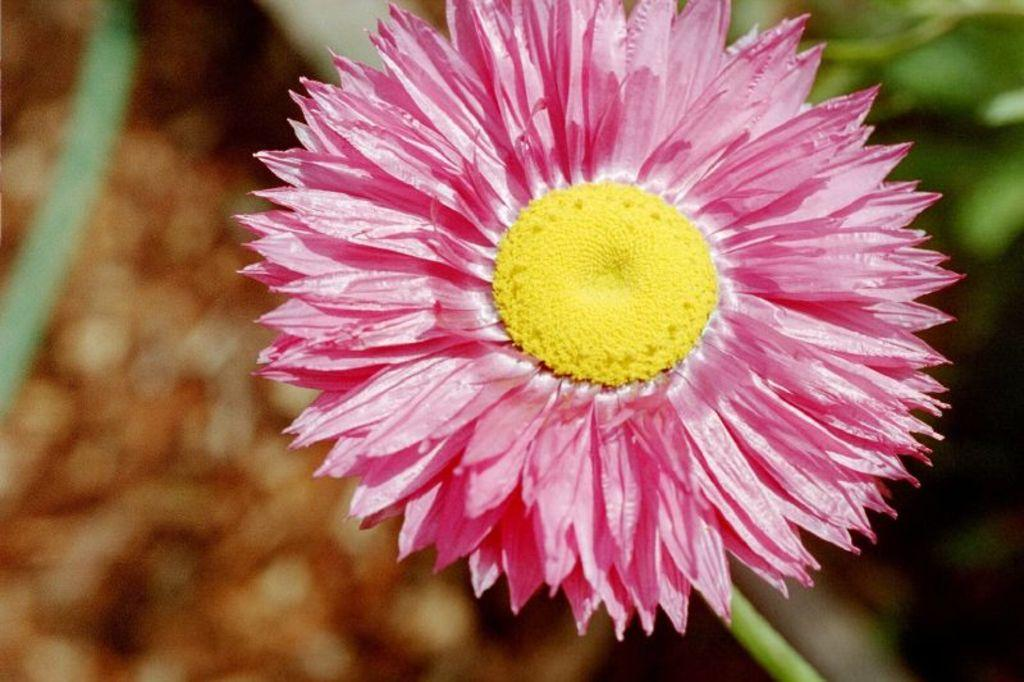What type of flower is in the image? There is a daisy flower in the image. What color are the petals of the flower? The petals of the flower are pink in color. Is there any part of the flower's stem visible in the image? Yes, there is a stem in the image. How would you describe the background of the image? The background of the image appears blurry. Can you hear the curtain crying in the image? There is no curtain or crying sound present in the image; it features a daisy flower with pink petals and a blurry background. 